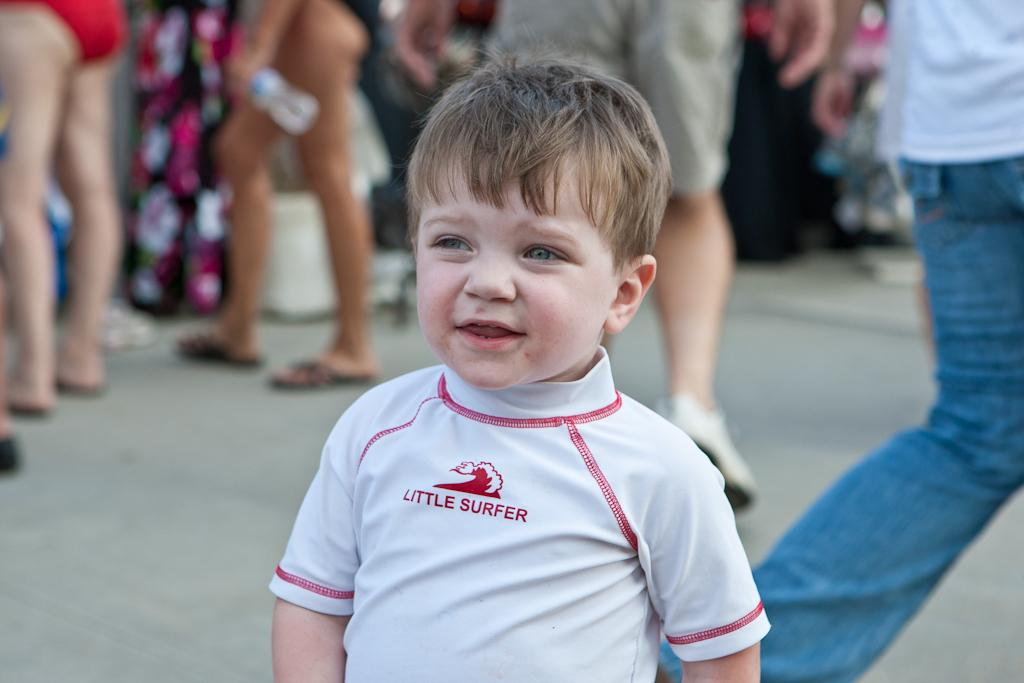Who is the main subject in the image? There is a small boy in the image. What is the boy doing in the image? The boy is standing on a path. What is the boy wearing in the image? The boy is wearing a white T-shirt. Can you describe the people's legs visible in the image? Some people are standing, while others are walking. What type of music can be heard playing in the background of the image? There is no music present in the image, as it is a still photograph. 